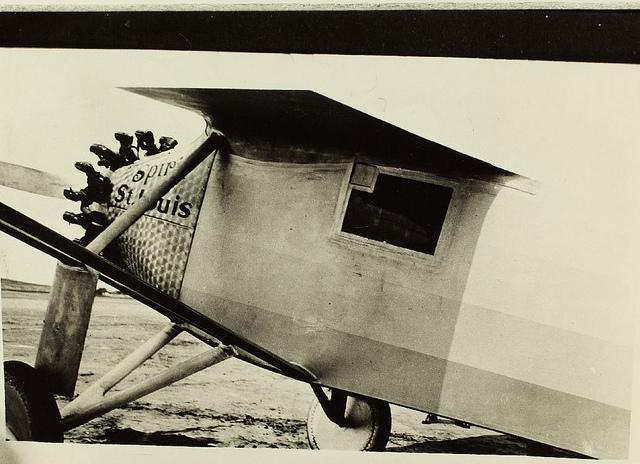How many airplanes are visible?
Give a very brief answer. 1. How many men are wearing orange vests on the tarmac?
Give a very brief answer. 0. 